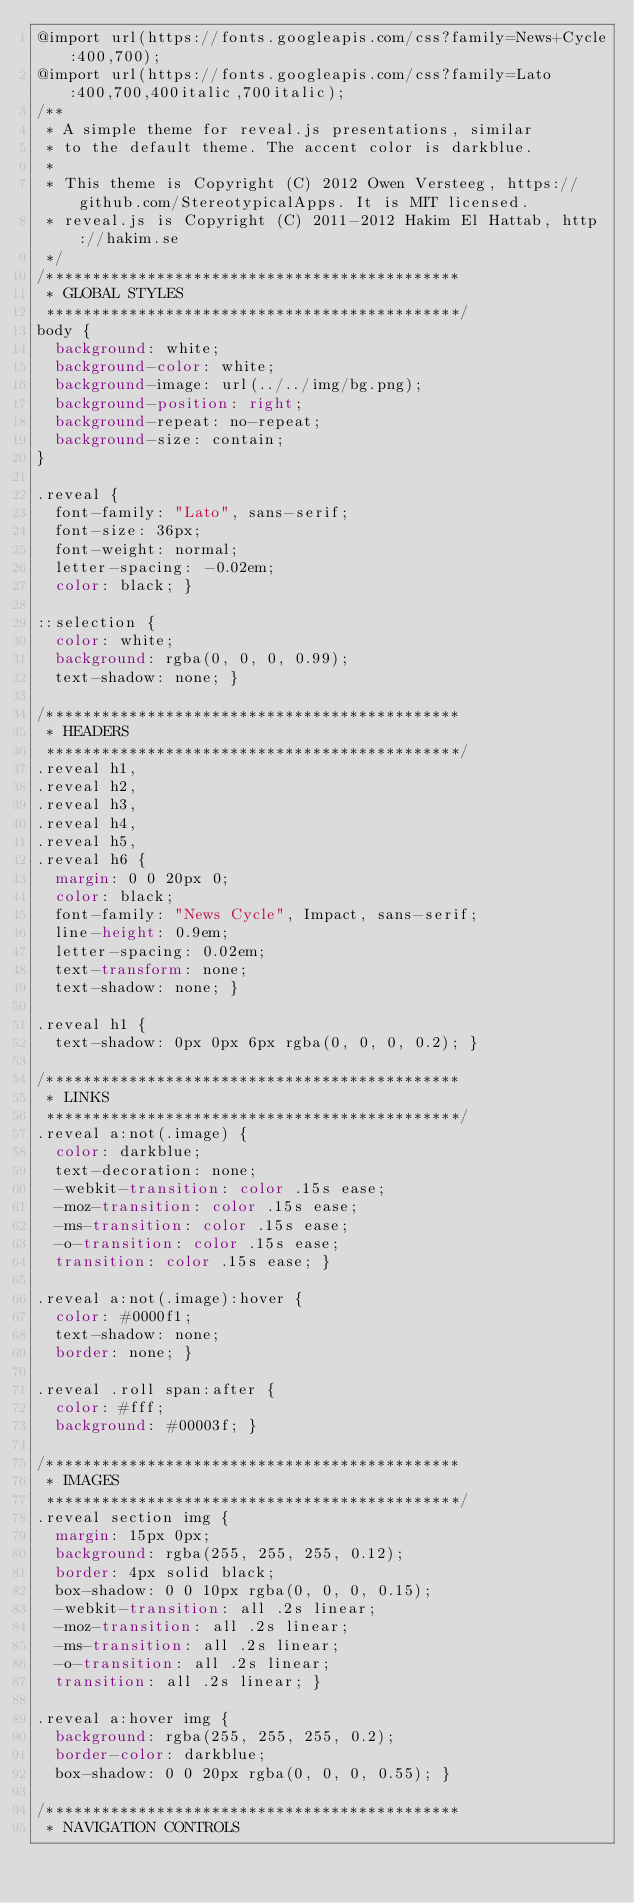<code> <loc_0><loc_0><loc_500><loc_500><_CSS_>@import url(https://fonts.googleapis.com/css?family=News+Cycle:400,700);
@import url(https://fonts.googleapis.com/css?family=Lato:400,700,400italic,700italic);
/**
 * A simple theme for reveal.js presentations, similar
 * to the default theme. The accent color is darkblue.
 *
 * This theme is Copyright (C) 2012 Owen Versteeg, https://github.com/StereotypicalApps. It is MIT licensed.
 * reveal.js is Copyright (C) 2011-2012 Hakim El Hattab, http://hakim.se
 */
/*********************************************
 * GLOBAL STYLES
 *********************************************/
body {
  background: white;
  background-color: white; 
  background-image: url(../../img/bg.png);
  background-position: right;
  background-repeat: no-repeat;
  background-size: contain;
}

.reveal {
  font-family: "Lato", sans-serif;
  font-size: 36px;
  font-weight: normal;
  letter-spacing: -0.02em;
  color: black; }

::selection {
  color: white;
  background: rgba(0, 0, 0, 0.99);
  text-shadow: none; }

/*********************************************
 * HEADERS
 *********************************************/
.reveal h1,
.reveal h2,
.reveal h3,
.reveal h4,
.reveal h5,
.reveal h6 {
  margin: 0 0 20px 0;
  color: black;
  font-family: "News Cycle", Impact, sans-serif;
  line-height: 0.9em;
  letter-spacing: 0.02em;
  text-transform: none;
  text-shadow: none; }

.reveal h1 {
  text-shadow: 0px 0px 6px rgba(0, 0, 0, 0.2); }

/*********************************************
 * LINKS
 *********************************************/
.reveal a:not(.image) {
  color: darkblue;
  text-decoration: none;
  -webkit-transition: color .15s ease;
  -moz-transition: color .15s ease;
  -ms-transition: color .15s ease;
  -o-transition: color .15s ease;
  transition: color .15s ease; }

.reveal a:not(.image):hover {
  color: #0000f1;
  text-shadow: none;
  border: none; }

.reveal .roll span:after {
  color: #fff;
  background: #00003f; }

/*********************************************
 * IMAGES
 *********************************************/
.reveal section img {
  margin: 15px 0px;
  background: rgba(255, 255, 255, 0.12);
  border: 4px solid black;
  box-shadow: 0 0 10px rgba(0, 0, 0, 0.15);
  -webkit-transition: all .2s linear;
  -moz-transition: all .2s linear;
  -ms-transition: all .2s linear;
  -o-transition: all .2s linear;
  transition: all .2s linear; }

.reveal a:hover img {
  background: rgba(255, 255, 255, 0.2);
  border-color: darkblue;
  box-shadow: 0 0 20px rgba(0, 0, 0, 0.55); }

/*********************************************
 * NAVIGATION CONTROLS</code> 